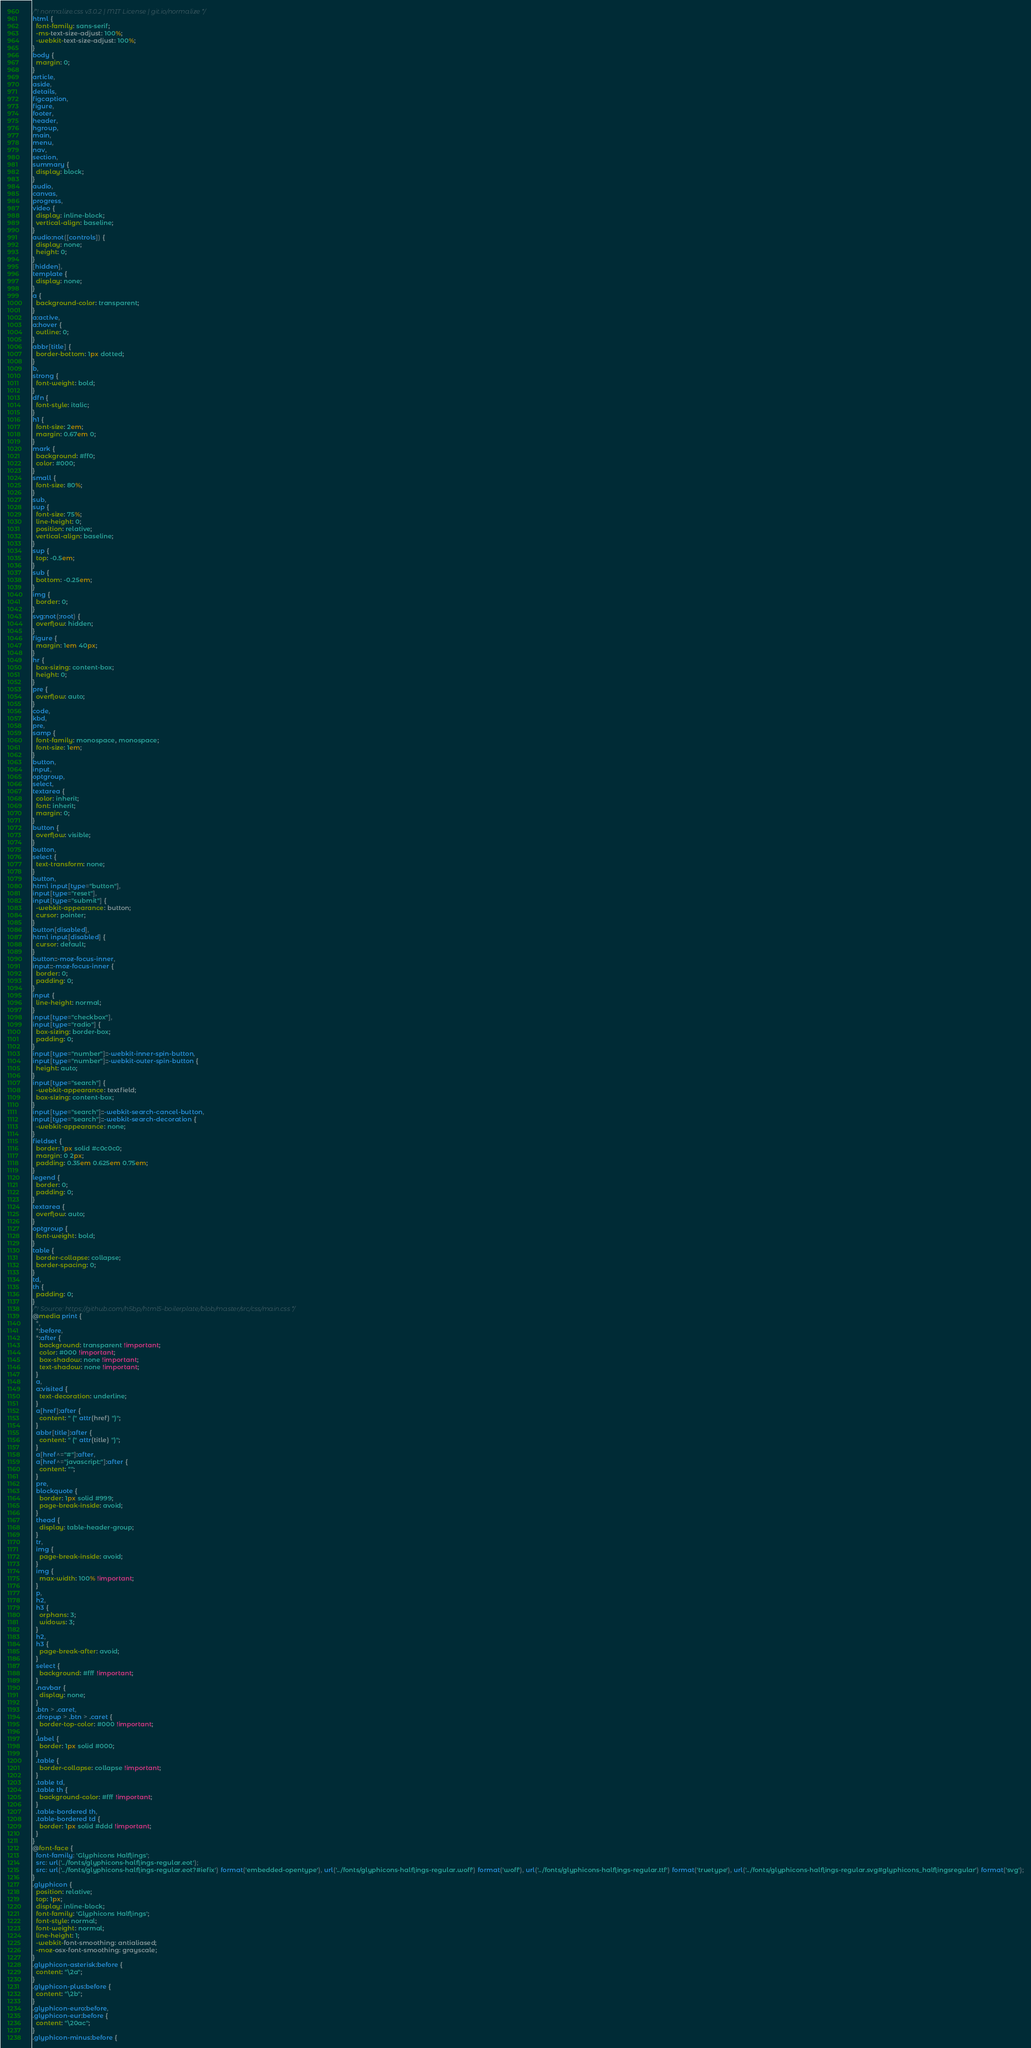Convert code to text. <code><loc_0><loc_0><loc_500><loc_500><_CSS_>/*! normalize.css v3.0.2 | MIT License | git.io/normalize */
html {
  font-family: sans-serif;
  -ms-text-size-adjust: 100%;
  -webkit-text-size-adjust: 100%;
}
body {
  margin: 0;
}
article,
aside,
details,
figcaption,
figure,
footer,
header,
hgroup,
main,
menu,
nav,
section,
summary {
  display: block;
}
audio,
canvas,
progress,
video {
  display: inline-block;
  vertical-align: baseline;
}
audio:not([controls]) {
  display: none;
  height: 0;
}
[hidden],
template {
  display: none;
}
a {
  background-color: transparent;
}
a:active,
a:hover {
  outline: 0;
}
abbr[title] {
  border-bottom: 1px dotted;
}
b,
strong {
  font-weight: bold;
}
dfn {
  font-style: italic;
}
h1 {
  font-size: 2em;
  margin: 0.67em 0;
}
mark {
  background: #ff0;
  color: #000;
}
small {
  font-size: 80%;
}
sub,
sup {
  font-size: 75%;
  line-height: 0;
  position: relative;
  vertical-align: baseline;
}
sup {
  top: -0.5em;
}
sub {
  bottom: -0.25em;
}
img {
  border: 0;
}
svg:not(:root) {
  overflow: hidden;
}
figure {
  margin: 1em 40px;
}
hr {
  box-sizing: content-box;
  height: 0;
}
pre {
  overflow: auto;
}
code,
kbd,
pre,
samp {
  font-family: monospace, monospace;
  font-size: 1em;
}
button,
input,
optgroup,
select,
textarea {
  color: inherit;
  font: inherit;
  margin: 0;
}
button {
  overflow: visible;
}
button,
select {
  text-transform: none;
}
button,
html input[type="button"],
input[type="reset"],
input[type="submit"] {
  -webkit-appearance: button;
  cursor: pointer;
}
button[disabled],
html input[disabled] {
  cursor: default;
}
button::-moz-focus-inner,
input::-moz-focus-inner {
  border: 0;
  padding: 0;
}
input {
  line-height: normal;
}
input[type="checkbox"],
input[type="radio"] {
  box-sizing: border-box;
  padding: 0;
}
input[type="number"]::-webkit-inner-spin-button,
input[type="number"]::-webkit-outer-spin-button {
  height: auto;
}
input[type="search"] {
  -webkit-appearance: textfield;
  box-sizing: content-box;
}
input[type="search"]::-webkit-search-cancel-button,
input[type="search"]::-webkit-search-decoration {
  -webkit-appearance: none;
}
fieldset {
  border: 1px solid #c0c0c0;
  margin: 0 2px;
  padding: 0.35em 0.625em 0.75em;
}
legend {
  border: 0;
  padding: 0;
}
textarea {
  overflow: auto;
}
optgroup {
  font-weight: bold;
}
table {
  border-collapse: collapse;
  border-spacing: 0;
}
td,
th {
  padding: 0;
}
/*! Source: https://github.com/h5bp/html5-boilerplate/blob/master/src/css/main.css */
@media print {
  *,
  *:before,
  *:after {
    background: transparent !important;
    color: #000 !important;
    box-shadow: none !important;
    text-shadow: none !important;
  }
  a,
  a:visited {
    text-decoration: underline;
  }
  a[href]:after {
    content: " (" attr(href) ")";
  }
  abbr[title]:after {
    content: " (" attr(title) ")";
  }
  a[href^="#"]:after,
  a[href^="javascript:"]:after {
    content: "";
  }
  pre,
  blockquote {
    border: 1px solid #999;
    page-break-inside: avoid;
  }
  thead {
    display: table-header-group;
  }
  tr,
  img {
    page-break-inside: avoid;
  }
  img {
    max-width: 100% !important;
  }
  p,
  h2,
  h3 {
    orphans: 3;
    widows: 3;
  }
  h2,
  h3 {
    page-break-after: avoid;
  }
  select {
    background: #fff !important;
  }
  .navbar {
    display: none;
  }
  .btn > .caret,
  .dropup > .btn > .caret {
    border-top-color: #000 !important;
  }
  .label {
    border: 1px solid #000;
  }
  .table {
    border-collapse: collapse !important;
  }
  .table td,
  .table th {
    background-color: #fff !important;
  }
  .table-bordered th,
  .table-bordered td {
    border: 1px solid #ddd !important;
  }
}
@font-face {
  font-family: 'Glyphicons Halflings';
  src: url('../fonts/glyphicons-halflings-regular.eot');
  src: url('../fonts/glyphicons-halflings-regular.eot?#iefix') format('embedded-opentype'), url('../fonts/glyphicons-halflings-regular.woff') format('woff'), url('../fonts/glyphicons-halflings-regular.ttf') format('truetype'), url('../fonts/glyphicons-halflings-regular.svg#glyphicons_halflingsregular') format('svg');
}
.glyphicon {
  position: relative;
  top: 1px;
  display: inline-block;
  font-family: 'Glyphicons Halflings';
  font-style: normal;
  font-weight: normal;
  line-height: 1;
  -webkit-font-smoothing: antialiased;
  -moz-osx-font-smoothing: grayscale;
}
.glyphicon-asterisk:before {
  content: "\2a";
}
.glyphicon-plus:before {
  content: "\2b";
}
.glyphicon-euro:before,
.glyphicon-eur:before {
  content: "\20ac";
}
.glyphicon-minus:before {</code> 